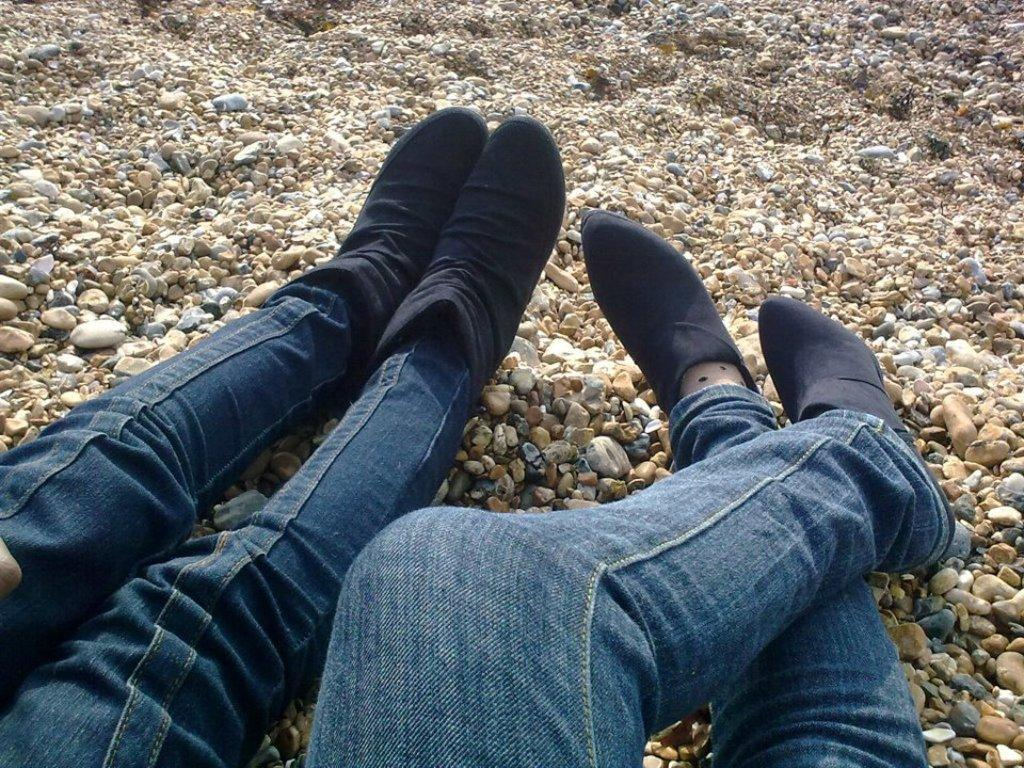Where was the image taken? The image was taken outdoors. What are the two persons in the image doing? The two persons are sitting on the ground. What is the texture of the ground in the image? The ground has pebbles. What type of desk can be seen in the image? There is no desk present in the image; it was taken outdoors with two persons sitting on the ground. 